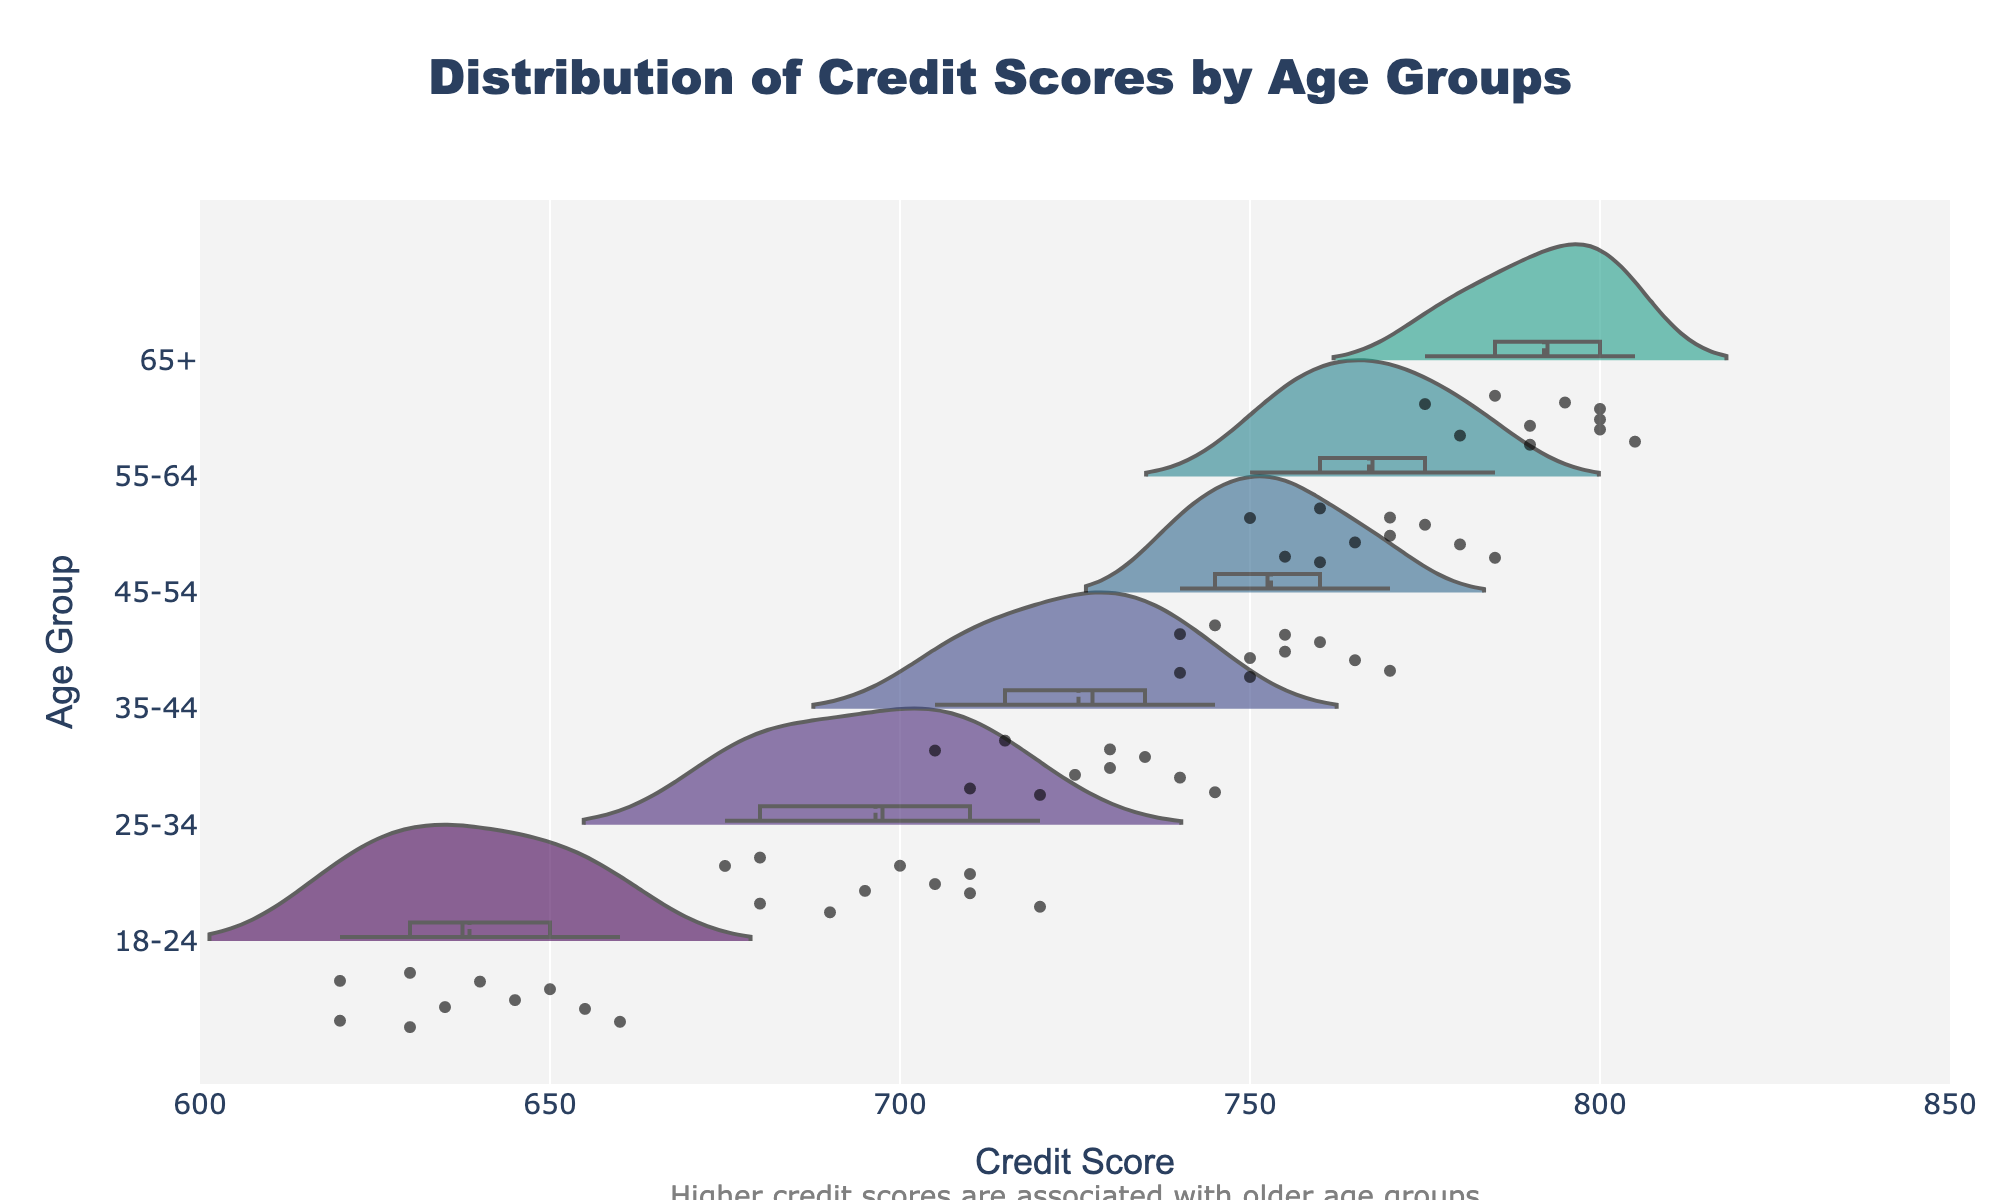What's the title of the figure? The title of the figure is written at the top center in a larger and bold font. It reads "Distribution of Credit Scores by Age Groups".
Answer: Distribution of Credit Scores by Age Groups Which age group has the highest median credit score? The age group with the highest median credit score is the 65+ group. This is identified by the position of the white dot inside the violin plot, which represents the median and appears further towards the right compared to other groups.
Answer: 65+ What is the range of credit scores for the 25-34 age group? The range of credit scores for the 25-34 age group can be determined by looking at the spread of the violin plot for that group, from the lowest to the highest point. The scores range approximately from 675 to 720.
Answer: 675-720 What is the color scheme used in the plots? Each age group's violin plot is colored using a sequential gradient from the Viridis color scale. This can be seen by observing the different shades employed for various age groups.
Answer: Viridis color scale Which age group shows the widest distribution of credit scores? The widest distribution of credit scores can be identified by inspecting the width of each violin plot. The 65+ age group shows the widest distribution as its plot spans the largest range.
Answer: 65+ How do the mean credit scores vary among the different age groups? Each violin plot has a solid black line indicating the mean credit score. By comparing these lines for each age group, we observe that the mean credit score increases with age, from 18-24 to 65+.
Answer: Increases with age from 18-24 to 65+ Which age group has the least variability in credit scores? The least variability can be observed by looking at the violin plots and determining which has the smallest vertical span. The 45-54 age group shows the least variability as its plot span is relatively narrow compared to others.
Answer: 45-54 Are there age groups where the actual data points are visible? Yes, the actual data points are visible on the plot as small jittered dots inside the violin plots for all age groups.
Answer: Yes What does the annotation below the plot state? There is a single text annotation below the plot indicating a key insight: "Higher credit scores are associated with older age groups".
Answer: Higher credit scores are associated with older age groups 